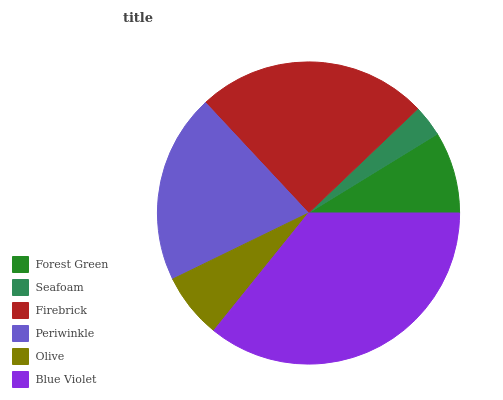Is Seafoam the minimum?
Answer yes or no. Yes. Is Blue Violet the maximum?
Answer yes or no. Yes. Is Firebrick the minimum?
Answer yes or no. No. Is Firebrick the maximum?
Answer yes or no. No. Is Firebrick greater than Seafoam?
Answer yes or no. Yes. Is Seafoam less than Firebrick?
Answer yes or no. Yes. Is Seafoam greater than Firebrick?
Answer yes or no. No. Is Firebrick less than Seafoam?
Answer yes or no. No. Is Periwinkle the high median?
Answer yes or no. Yes. Is Forest Green the low median?
Answer yes or no. Yes. Is Olive the high median?
Answer yes or no. No. Is Firebrick the low median?
Answer yes or no. No. 